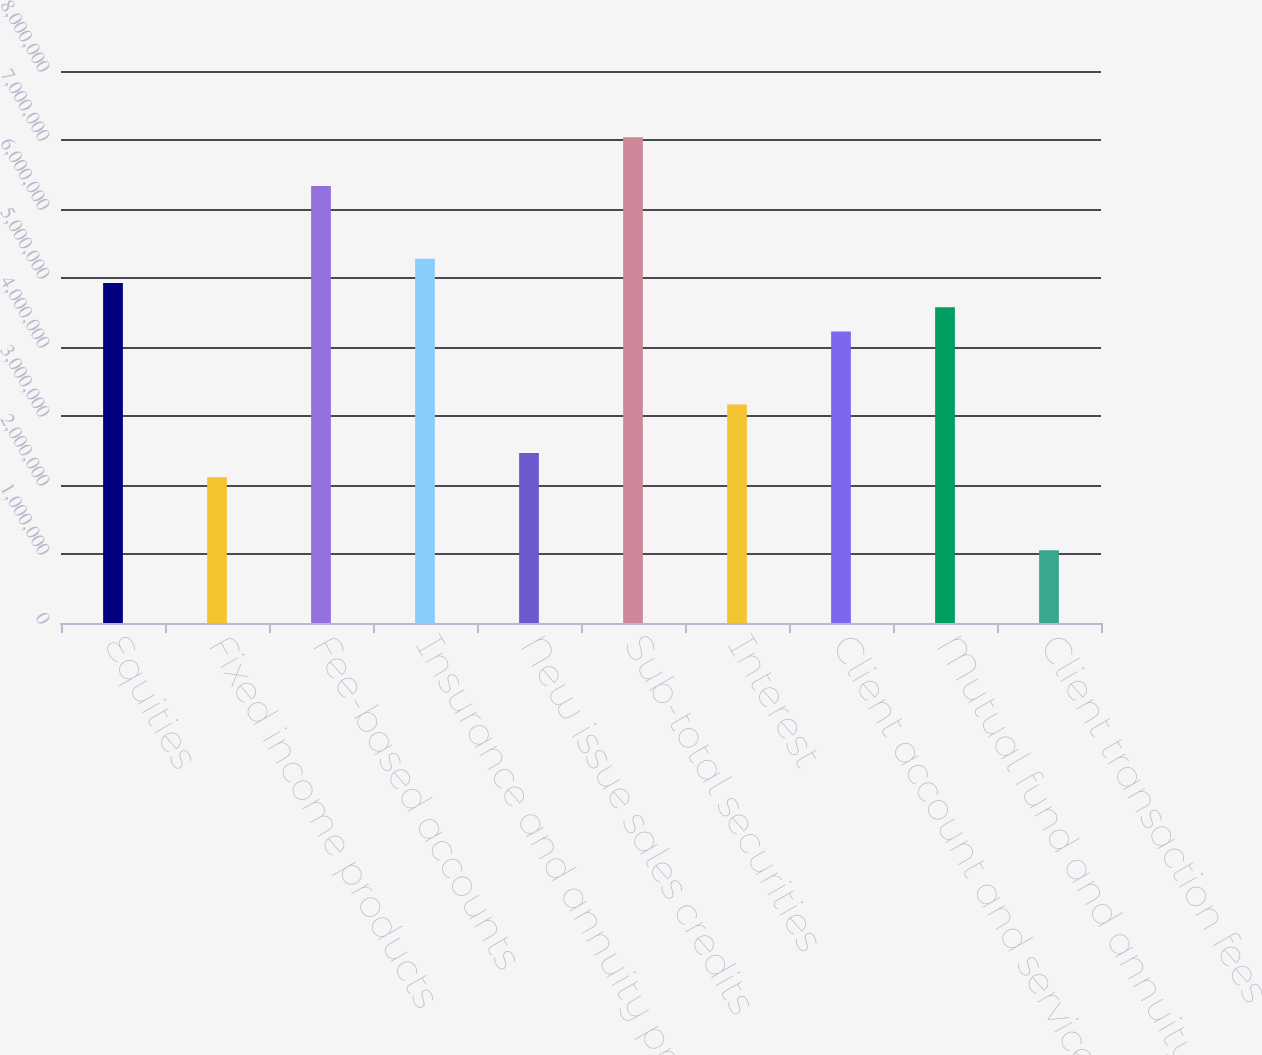<chart> <loc_0><loc_0><loc_500><loc_500><bar_chart><fcel>Equities<fcel>Fixed income products<fcel>Fee-based accounts<fcel>Insurance and annuity products<fcel>New issue sales credits<fcel>Sub-total securities<fcel>Interest<fcel>Client account and service<fcel>Mutual fund and annuity<fcel>Client transaction fees<nl><fcel>4.92727e+06<fcel>2.11185e+06<fcel>6.33498e+06<fcel>5.2792e+06<fcel>2.46378e+06<fcel>7.03883e+06<fcel>3.16763e+06<fcel>4.22341e+06<fcel>4.57534e+06<fcel>1.05607e+06<nl></chart> 